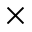<formula> <loc_0><loc_0><loc_500><loc_500>\times</formula> 